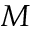<formula> <loc_0><loc_0><loc_500><loc_500>M</formula> 